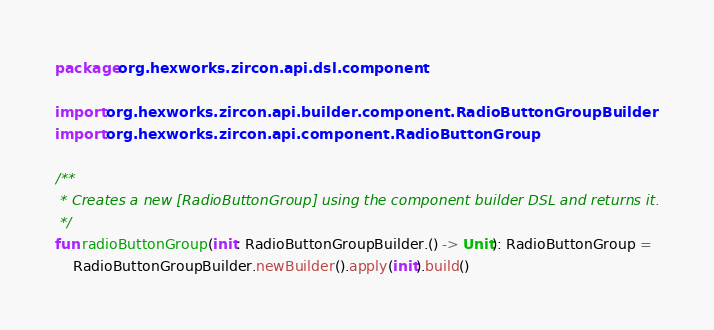Convert code to text. <code><loc_0><loc_0><loc_500><loc_500><_Kotlin_>package org.hexworks.zircon.api.dsl.component

import org.hexworks.zircon.api.builder.component.RadioButtonGroupBuilder
import org.hexworks.zircon.api.component.RadioButtonGroup

/**
 * Creates a new [RadioButtonGroup] using the component builder DSL and returns it.
 */
fun radioButtonGroup(init: RadioButtonGroupBuilder.() -> Unit): RadioButtonGroup =
    RadioButtonGroupBuilder.newBuilder().apply(init).build()
</code> 